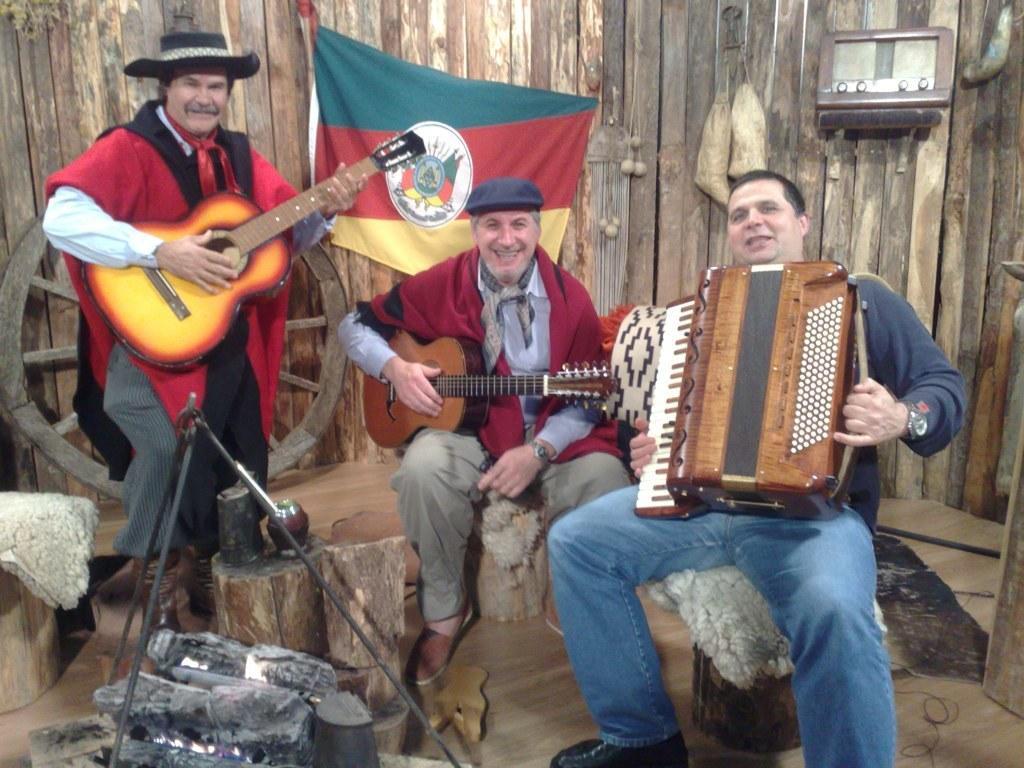Could you give a brief overview of what you see in this image? In this image we can see a person sitting. He is holding an accordion. And he is wearing watch. Another person is wearing cap and holding guitar and sitting. Another person is wearing hat and holding guitar. In front of them there is a stand. Also there is a wooden wall. On the wall there is a flag. Also there is a wheel. And there are few other items. 